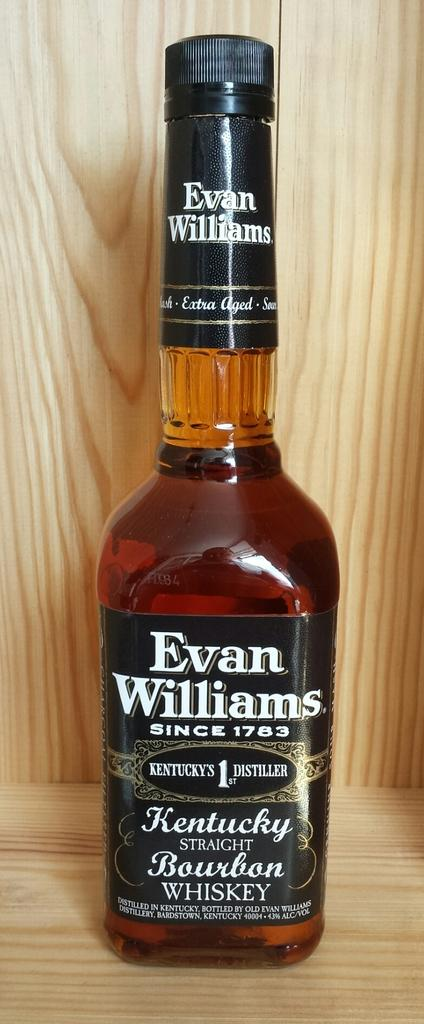<image>
Create a compact narrative representing the image presented. A bottle of Evan Williams sitting on a wood shelf 